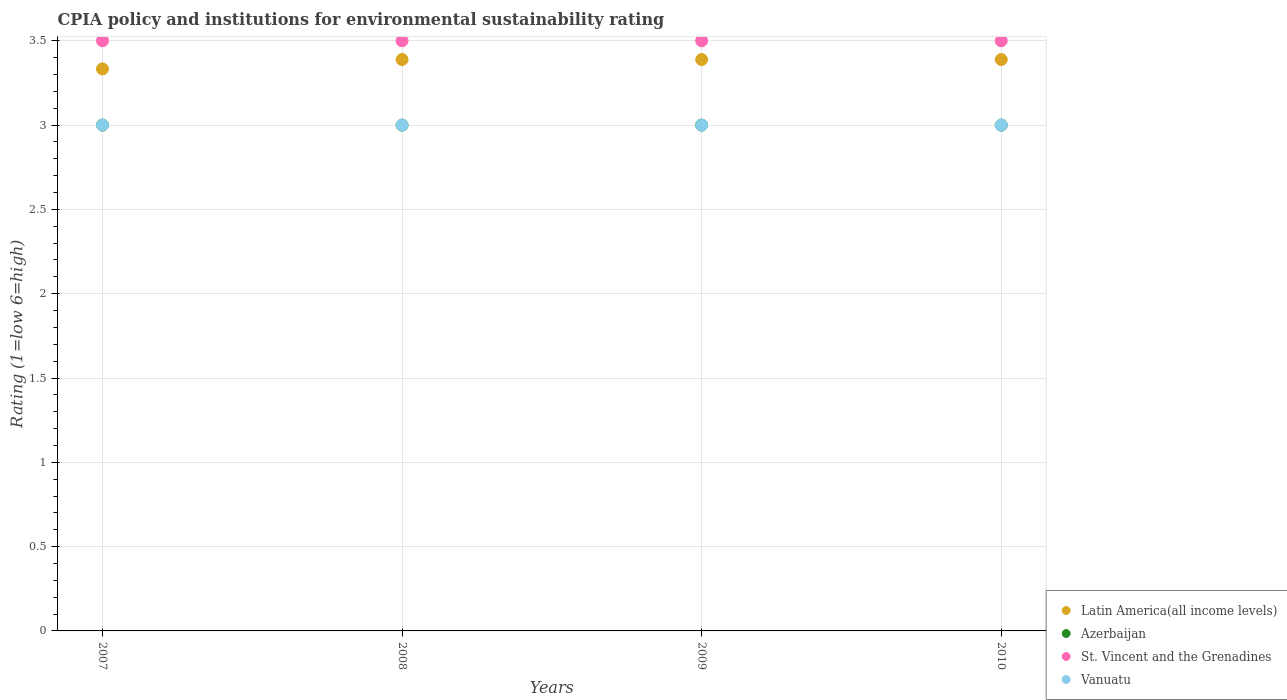Is the number of dotlines equal to the number of legend labels?
Provide a succinct answer. Yes. What is the CPIA rating in Latin America(all income levels) in 2009?
Your answer should be very brief. 3.39. Across all years, what is the maximum CPIA rating in Vanuatu?
Your answer should be very brief. 3. Across all years, what is the minimum CPIA rating in Latin America(all income levels)?
Offer a very short reply. 3.33. In which year was the CPIA rating in St. Vincent and the Grenadines minimum?
Keep it short and to the point. 2007. What is the average CPIA rating in St. Vincent and the Grenadines per year?
Offer a very short reply. 3.5. In the year 2009, what is the difference between the CPIA rating in Azerbaijan and CPIA rating in Vanuatu?
Keep it short and to the point. 0. In how many years, is the CPIA rating in St. Vincent and the Grenadines greater than 0.7?
Provide a succinct answer. 4. Is the CPIA rating in Vanuatu in 2007 less than that in 2010?
Your answer should be very brief. No. What is the difference between the highest and the lowest CPIA rating in Latin America(all income levels)?
Make the answer very short. 0.06. Is the sum of the CPIA rating in St. Vincent and the Grenadines in 2007 and 2008 greater than the maximum CPIA rating in Vanuatu across all years?
Provide a short and direct response. Yes. Does the CPIA rating in Azerbaijan monotonically increase over the years?
Provide a short and direct response. No. Is the CPIA rating in Latin America(all income levels) strictly less than the CPIA rating in St. Vincent and the Grenadines over the years?
Offer a terse response. Yes. What is the difference between two consecutive major ticks on the Y-axis?
Make the answer very short. 0.5. Does the graph contain any zero values?
Your response must be concise. No. Does the graph contain grids?
Your response must be concise. Yes. How many legend labels are there?
Ensure brevity in your answer.  4. What is the title of the graph?
Your answer should be compact. CPIA policy and institutions for environmental sustainability rating. Does "Sao Tome and Principe" appear as one of the legend labels in the graph?
Your answer should be compact. No. What is the Rating (1=low 6=high) in Latin America(all income levels) in 2007?
Offer a very short reply. 3.33. What is the Rating (1=low 6=high) in Azerbaijan in 2007?
Give a very brief answer. 3. What is the Rating (1=low 6=high) of St. Vincent and the Grenadines in 2007?
Offer a very short reply. 3.5. What is the Rating (1=low 6=high) in Latin America(all income levels) in 2008?
Ensure brevity in your answer.  3.39. What is the Rating (1=low 6=high) of Azerbaijan in 2008?
Give a very brief answer. 3. What is the Rating (1=low 6=high) of Vanuatu in 2008?
Ensure brevity in your answer.  3. What is the Rating (1=low 6=high) in Latin America(all income levels) in 2009?
Offer a terse response. 3.39. What is the Rating (1=low 6=high) of Latin America(all income levels) in 2010?
Make the answer very short. 3.39. What is the Rating (1=low 6=high) of Azerbaijan in 2010?
Your answer should be very brief. 3. What is the Rating (1=low 6=high) in St. Vincent and the Grenadines in 2010?
Give a very brief answer. 3.5. What is the Rating (1=low 6=high) in Vanuatu in 2010?
Make the answer very short. 3. Across all years, what is the maximum Rating (1=low 6=high) in Latin America(all income levels)?
Make the answer very short. 3.39. Across all years, what is the maximum Rating (1=low 6=high) of Azerbaijan?
Ensure brevity in your answer.  3. Across all years, what is the maximum Rating (1=low 6=high) of St. Vincent and the Grenadines?
Give a very brief answer. 3.5. Across all years, what is the maximum Rating (1=low 6=high) in Vanuatu?
Your answer should be compact. 3. Across all years, what is the minimum Rating (1=low 6=high) in Latin America(all income levels)?
Offer a terse response. 3.33. Across all years, what is the minimum Rating (1=low 6=high) of St. Vincent and the Grenadines?
Make the answer very short. 3.5. What is the total Rating (1=low 6=high) in Azerbaijan in the graph?
Provide a short and direct response. 12. What is the difference between the Rating (1=low 6=high) in Latin America(all income levels) in 2007 and that in 2008?
Make the answer very short. -0.06. What is the difference between the Rating (1=low 6=high) in Azerbaijan in 2007 and that in 2008?
Offer a very short reply. 0. What is the difference between the Rating (1=low 6=high) in St. Vincent and the Grenadines in 2007 and that in 2008?
Offer a very short reply. 0. What is the difference between the Rating (1=low 6=high) in Vanuatu in 2007 and that in 2008?
Make the answer very short. 0. What is the difference between the Rating (1=low 6=high) of Latin America(all income levels) in 2007 and that in 2009?
Keep it short and to the point. -0.06. What is the difference between the Rating (1=low 6=high) in Azerbaijan in 2007 and that in 2009?
Provide a succinct answer. 0. What is the difference between the Rating (1=low 6=high) in St. Vincent and the Grenadines in 2007 and that in 2009?
Provide a succinct answer. 0. What is the difference between the Rating (1=low 6=high) of Vanuatu in 2007 and that in 2009?
Ensure brevity in your answer.  0. What is the difference between the Rating (1=low 6=high) of Latin America(all income levels) in 2007 and that in 2010?
Ensure brevity in your answer.  -0.06. What is the difference between the Rating (1=low 6=high) of St. Vincent and the Grenadines in 2008 and that in 2009?
Make the answer very short. 0. What is the difference between the Rating (1=low 6=high) of Vanuatu in 2008 and that in 2009?
Offer a very short reply. 0. What is the difference between the Rating (1=low 6=high) of Azerbaijan in 2008 and that in 2010?
Your answer should be very brief. 0. What is the difference between the Rating (1=low 6=high) of Latin America(all income levels) in 2009 and that in 2010?
Give a very brief answer. 0. What is the difference between the Rating (1=low 6=high) in Azerbaijan in 2009 and that in 2010?
Offer a terse response. 0. What is the difference between the Rating (1=low 6=high) of St. Vincent and the Grenadines in 2009 and that in 2010?
Keep it short and to the point. 0. What is the difference between the Rating (1=low 6=high) of Latin America(all income levels) in 2007 and the Rating (1=low 6=high) of St. Vincent and the Grenadines in 2008?
Offer a terse response. -0.17. What is the difference between the Rating (1=low 6=high) of Azerbaijan in 2007 and the Rating (1=low 6=high) of St. Vincent and the Grenadines in 2008?
Provide a succinct answer. -0.5. What is the difference between the Rating (1=low 6=high) of Azerbaijan in 2007 and the Rating (1=low 6=high) of Vanuatu in 2008?
Your answer should be compact. 0. What is the difference between the Rating (1=low 6=high) of St. Vincent and the Grenadines in 2007 and the Rating (1=low 6=high) of Vanuatu in 2008?
Your answer should be very brief. 0.5. What is the difference between the Rating (1=low 6=high) of Azerbaijan in 2007 and the Rating (1=low 6=high) of Vanuatu in 2009?
Provide a short and direct response. 0. What is the difference between the Rating (1=low 6=high) of Latin America(all income levels) in 2007 and the Rating (1=low 6=high) of Azerbaijan in 2010?
Your answer should be very brief. 0.33. What is the difference between the Rating (1=low 6=high) of Azerbaijan in 2007 and the Rating (1=low 6=high) of St. Vincent and the Grenadines in 2010?
Offer a very short reply. -0.5. What is the difference between the Rating (1=low 6=high) of St. Vincent and the Grenadines in 2007 and the Rating (1=low 6=high) of Vanuatu in 2010?
Offer a very short reply. 0.5. What is the difference between the Rating (1=low 6=high) in Latin America(all income levels) in 2008 and the Rating (1=low 6=high) in Azerbaijan in 2009?
Provide a short and direct response. 0.39. What is the difference between the Rating (1=low 6=high) of Latin America(all income levels) in 2008 and the Rating (1=low 6=high) of St. Vincent and the Grenadines in 2009?
Keep it short and to the point. -0.11. What is the difference between the Rating (1=low 6=high) of Latin America(all income levels) in 2008 and the Rating (1=low 6=high) of Vanuatu in 2009?
Make the answer very short. 0.39. What is the difference between the Rating (1=low 6=high) in Azerbaijan in 2008 and the Rating (1=low 6=high) in St. Vincent and the Grenadines in 2009?
Offer a very short reply. -0.5. What is the difference between the Rating (1=low 6=high) in Azerbaijan in 2008 and the Rating (1=low 6=high) in Vanuatu in 2009?
Your response must be concise. 0. What is the difference between the Rating (1=low 6=high) in St. Vincent and the Grenadines in 2008 and the Rating (1=low 6=high) in Vanuatu in 2009?
Provide a short and direct response. 0.5. What is the difference between the Rating (1=low 6=high) in Latin America(all income levels) in 2008 and the Rating (1=low 6=high) in Azerbaijan in 2010?
Offer a terse response. 0.39. What is the difference between the Rating (1=low 6=high) in Latin America(all income levels) in 2008 and the Rating (1=low 6=high) in St. Vincent and the Grenadines in 2010?
Offer a very short reply. -0.11. What is the difference between the Rating (1=low 6=high) of Latin America(all income levels) in 2008 and the Rating (1=low 6=high) of Vanuatu in 2010?
Offer a very short reply. 0.39. What is the difference between the Rating (1=low 6=high) in Latin America(all income levels) in 2009 and the Rating (1=low 6=high) in Azerbaijan in 2010?
Give a very brief answer. 0.39. What is the difference between the Rating (1=low 6=high) of Latin America(all income levels) in 2009 and the Rating (1=low 6=high) of St. Vincent and the Grenadines in 2010?
Offer a very short reply. -0.11. What is the difference between the Rating (1=low 6=high) of Latin America(all income levels) in 2009 and the Rating (1=low 6=high) of Vanuatu in 2010?
Ensure brevity in your answer.  0.39. What is the difference between the Rating (1=low 6=high) of St. Vincent and the Grenadines in 2009 and the Rating (1=low 6=high) of Vanuatu in 2010?
Ensure brevity in your answer.  0.5. What is the average Rating (1=low 6=high) of Latin America(all income levels) per year?
Your answer should be compact. 3.38. What is the average Rating (1=low 6=high) in Azerbaijan per year?
Keep it short and to the point. 3. What is the average Rating (1=low 6=high) of St. Vincent and the Grenadines per year?
Offer a very short reply. 3.5. In the year 2007, what is the difference between the Rating (1=low 6=high) of Latin America(all income levels) and Rating (1=low 6=high) of Azerbaijan?
Keep it short and to the point. 0.33. In the year 2007, what is the difference between the Rating (1=low 6=high) in Azerbaijan and Rating (1=low 6=high) in Vanuatu?
Offer a very short reply. 0. In the year 2007, what is the difference between the Rating (1=low 6=high) of St. Vincent and the Grenadines and Rating (1=low 6=high) of Vanuatu?
Provide a succinct answer. 0.5. In the year 2008, what is the difference between the Rating (1=low 6=high) in Latin America(all income levels) and Rating (1=low 6=high) in Azerbaijan?
Offer a terse response. 0.39. In the year 2008, what is the difference between the Rating (1=low 6=high) of Latin America(all income levels) and Rating (1=low 6=high) of St. Vincent and the Grenadines?
Your answer should be compact. -0.11. In the year 2008, what is the difference between the Rating (1=low 6=high) in Latin America(all income levels) and Rating (1=low 6=high) in Vanuatu?
Your response must be concise. 0.39. In the year 2008, what is the difference between the Rating (1=low 6=high) of Azerbaijan and Rating (1=low 6=high) of Vanuatu?
Provide a succinct answer. 0. In the year 2009, what is the difference between the Rating (1=low 6=high) in Latin America(all income levels) and Rating (1=low 6=high) in Azerbaijan?
Provide a succinct answer. 0.39. In the year 2009, what is the difference between the Rating (1=low 6=high) in Latin America(all income levels) and Rating (1=low 6=high) in St. Vincent and the Grenadines?
Provide a short and direct response. -0.11. In the year 2009, what is the difference between the Rating (1=low 6=high) of Latin America(all income levels) and Rating (1=low 6=high) of Vanuatu?
Provide a short and direct response. 0.39. In the year 2009, what is the difference between the Rating (1=low 6=high) of Azerbaijan and Rating (1=low 6=high) of St. Vincent and the Grenadines?
Provide a short and direct response. -0.5. In the year 2009, what is the difference between the Rating (1=low 6=high) of St. Vincent and the Grenadines and Rating (1=low 6=high) of Vanuatu?
Make the answer very short. 0.5. In the year 2010, what is the difference between the Rating (1=low 6=high) of Latin America(all income levels) and Rating (1=low 6=high) of Azerbaijan?
Ensure brevity in your answer.  0.39. In the year 2010, what is the difference between the Rating (1=low 6=high) of Latin America(all income levels) and Rating (1=low 6=high) of St. Vincent and the Grenadines?
Make the answer very short. -0.11. In the year 2010, what is the difference between the Rating (1=low 6=high) of Latin America(all income levels) and Rating (1=low 6=high) of Vanuatu?
Offer a very short reply. 0.39. In the year 2010, what is the difference between the Rating (1=low 6=high) of Azerbaijan and Rating (1=low 6=high) of Vanuatu?
Your answer should be compact. 0. What is the ratio of the Rating (1=low 6=high) of Latin America(all income levels) in 2007 to that in 2008?
Provide a short and direct response. 0.98. What is the ratio of the Rating (1=low 6=high) of Latin America(all income levels) in 2007 to that in 2009?
Provide a short and direct response. 0.98. What is the ratio of the Rating (1=low 6=high) of Azerbaijan in 2007 to that in 2009?
Your answer should be very brief. 1. What is the ratio of the Rating (1=low 6=high) of Latin America(all income levels) in 2007 to that in 2010?
Provide a short and direct response. 0.98. What is the ratio of the Rating (1=low 6=high) of St. Vincent and the Grenadines in 2007 to that in 2010?
Keep it short and to the point. 1. What is the ratio of the Rating (1=low 6=high) of Vanuatu in 2007 to that in 2010?
Your answer should be very brief. 1. What is the ratio of the Rating (1=low 6=high) in Azerbaijan in 2008 to that in 2009?
Provide a short and direct response. 1. What is the ratio of the Rating (1=low 6=high) in Latin America(all income levels) in 2008 to that in 2010?
Provide a succinct answer. 1. What is the ratio of the Rating (1=low 6=high) of St. Vincent and the Grenadines in 2008 to that in 2010?
Provide a succinct answer. 1. What is the ratio of the Rating (1=low 6=high) of Vanuatu in 2008 to that in 2010?
Offer a very short reply. 1. What is the ratio of the Rating (1=low 6=high) of Azerbaijan in 2009 to that in 2010?
Your answer should be very brief. 1. What is the difference between the highest and the second highest Rating (1=low 6=high) of St. Vincent and the Grenadines?
Your answer should be compact. 0. What is the difference between the highest and the second highest Rating (1=low 6=high) in Vanuatu?
Provide a succinct answer. 0. What is the difference between the highest and the lowest Rating (1=low 6=high) of Latin America(all income levels)?
Ensure brevity in your answer.  0.06. What is the difference between the highest and the lowest Rating (1=low 6=high) of St. Vincent and the Grenadines?
Ensure brevity in your answer.  0. 